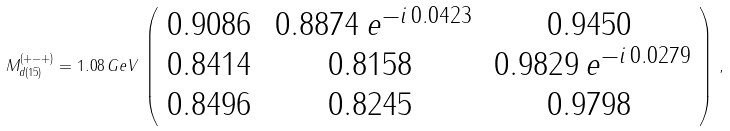<formula> <loc_0><loc_0><loc_500><loc_500>M _ { d ( 1 5 ) } ^ { ( + - + ) } = 1 . 0 8 \, G e V \, \left ( \begin{array} { c c c } 0 . 9 0 8 6 & \, 0 . 8 8 7 4 \, e ^ { - i \, 0 . 0 4 2 3 } & 0 . 9 4 5 0 \\ 0 . 8 4 1 4 & 0 . 8 1 5 8 & \, 0 . 9 8 2 9 \, e ^ { - i \, 0 . 0 2 7 9 } \\ 0 . 8 4 9 6 & 0 . 8 2 4 5 & 0 . 9 7 9 8 \end{array} \right ) \, ,</formula> 